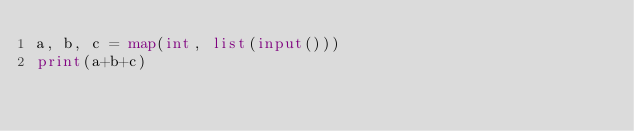<code> <loc_0><loc_0><loc_500><loc_500><_Python_>a, b, c = map(int, list(input()))
print(a+b+c)</code> 